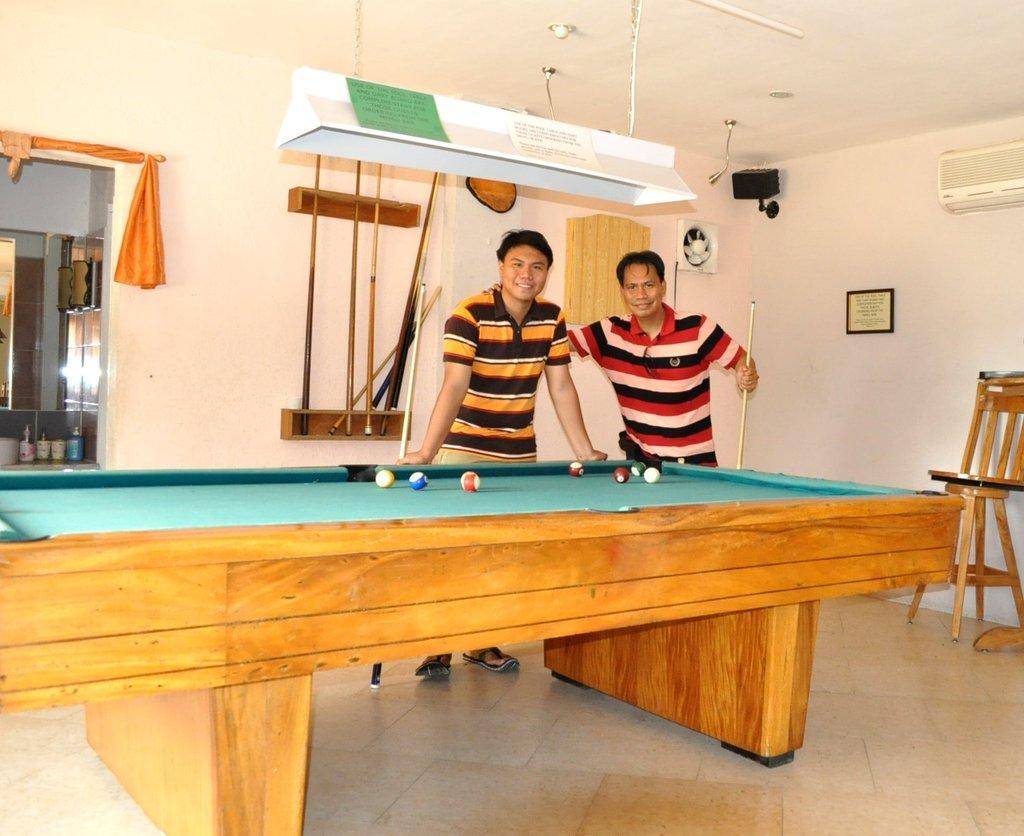In one or two sentences, can you explain what this image depicts? This picture is clicked in a room. Here, we see snooker pool game. Two men are standing beside the table and both of them are smiling. Behind them, we see a white wall on which white board is placed. Beside that, we see orange curtain. 